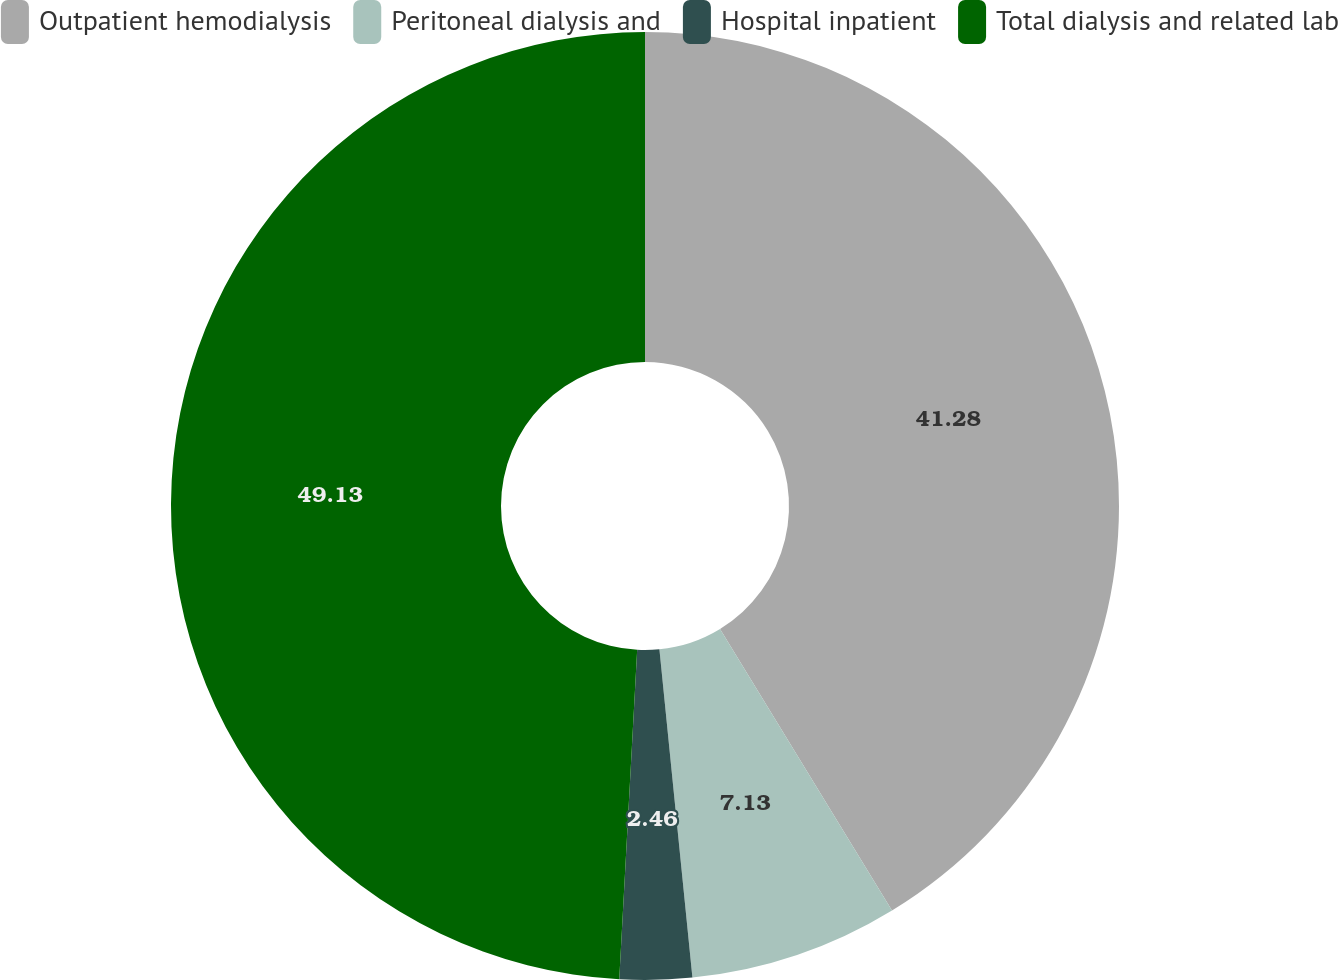Convert chart to OTSL. <chart><loc_0><loc_0><loc_500><loc_500><pie_chart><fcel>Outpatient hemodialysis<fcel>Peritoneal dialysis and<fcel>Hospital inpatient<fcel>Total dialysis and related lab<nl><fcel>41.28%<fcel>7.13%<fcel>2.46%<fcel>49.14%<nl></chart> 